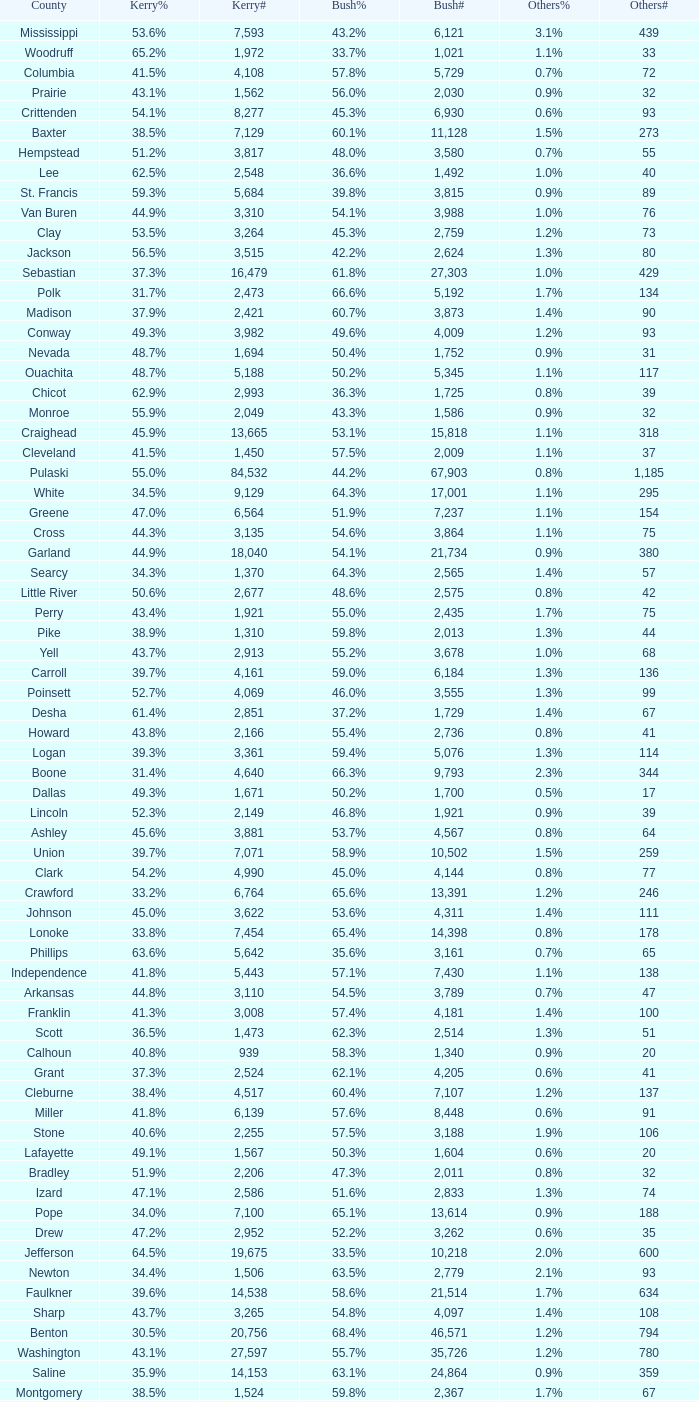Give me the full table as a dictionary. {'header': ['County', 'Kerry%', 'Kerry#', 'Bush%', 'Bush#', 'Others%', 'Others#'], 'rows': [['Mississippi', '53.6%', '7,593', '43.2%', '6,121', '3.1%', '439'], ['Woodruff', '65.2%', '1,972', '33.7%', '1,021', '1.1%', '33'], ['Columbia', '41.5%', '4,108', '57.8%', '5,729', '0.7%', '72'], ['Prairie', '43.1%', '1,562', '56.0%', '2,030', '0.9%', '32'], ['Crittenden', '54.1%', '8,277', '45.3%', '6,930', '0.6%', '93'], ['Baxter', '38.5%', '7,129', '60.1%', '11,128', '1.5%', '273'], ['Hempstead', '51.2%', '3,817', '48.0%', '3,580', '0.7%', '55'], ['Lee', '62.5%', '2,548', '36.6%', '1,492', '1.0%', '40'], ['St. Francis', '59.3%', '5,684', '39.8%', '3,815', '0.9%', '89'], ['Van Buren', '44.9%', '3,310', '54.1%', '3,988', '1.0%', '76'], ['Clay', '53.5%', '3,264', '45.3%', '2,759', '1.2%', '73'], ['Jackson', '56.5%', '3,515', '42.2%', '2,624', '1.3%', '80'], ['Sebastian', '37.3%', '16,479', '61.8%', '27,303', '1.0%', '429'], ['Polk', '31.7%', '2,473', '66.6%', '5,192', '1.7%', '134'], ['Madison', '37.9%', '2,421', '60.7%', '3,873', '1.4%', '90'], ['Conway', '49.3%', '3,982', '49.6%', '4,009', '1.2%', '93'], ['Nevada', '48.7%', '1,694', '50.4%', '1,752', '0.9%', '31'], ['Ouachita', '48.7%', '5,188', '50.2%', '5,345', '1.1%', '117'], ['Chicot', '62.9%', '2,993', '36.3%', '1,725', '0.8%', '39'], ['Monroe', '55.9%', '2,049', '43.3%', '1,586', '0.9%', '32'], ['Craighead', '45.9%', '13,665', '53.1%', '15,818', '1.1%', '318'], ['Cleveland', '41.5%', '1,450', '57.5%', '2,009', '1.1%', '37'], ['Pulaski', '55.0%', '84,532', '44.2%', '67,903', '0.8%', '1,185'], ['White', '34.5%', '9,129', '64.3%', '17,001', '1.1%', '295'], ['Greene', '47.0%', '6,564', '51.9%', '7,237', '1.1%', '154'], ['Cross', '44.3%', '3,135', '54.6%', '3,864', '1.1%', '75'], ['Garland', '44.9%', '18,040', '54.1%', '21,734', '0.9%', '380'], ['Searcy', '34.3%', '1,370', '64.3%', '2,565', '1.4%', '57'], ['Little River', '50.6%', '2,677', '48.6%', '2,575', '0.8%', '42'], ['Perry', '43.4%', '1,921', '55.0%', '2,435', '1.7%', '75'], ['Pike', '38.9%', '1,310', '59.8%', '2,013', '1.3%', '44'], ['Yell', '43.7%', '2,913', '55.2%', '3,678', '1.0%', '68'], ['Carroll', '39.7%', '4,161', '59.0%', '6,184', '1.3%', '136'], ['Poinsett', '52.7%', '4,069', '46.0%', '3,555', '1.3%', '99'], ['Desha', '61.4%', '2,851', '37.2%', '1,729', '1.4%', '67'], ['Howard', '43.8%', '2,166', '55.4%', '2,736', '0.8%', '41'], ['Logan', '39.3%', '3,361', '59.4%', '5,076', '1.3%', '114'], ['Boone', '31.4%', '4,640', '66.3%', '9,793', '2.3%', '344'], ['Dallas', '49.3%', '1,671', '50.2%', '1,700', '0.5%', '17'], ['Lincoln', '52.3%', '2,149', '46.8%', '1,921', '0.9%', '39'], ['Ashley', '45.6%', '3,881', '53.7%', '4,567', '0.8%', '64'], ['Union', '39.7%', '7,071', '58.9%', '10,502', '1.5%', '259'], ['Clark', '54.2%', '4,990', '45.0%', '4,144', '0.8%', '77'], ['Crawford', '33.2%', '6,764', '65.6%', '13,391', '1.2%', '246'], ['Johnson', '45.0%', '3,622', '53.6%', '4,311', '1.4%', '111'], ['Lonoke', '33.8%', '7,454', '65.4%', '14,398', '0.8%', '178'], ['Phillips', '63.6%', '5,642', '35.6%', '3,161', '0.7%', '65'], ['Independence', '41.8%', '5,443', '57.1%', '7,430', '1.1%', '138'], ['Arkansas', '44.8%', '3,110', '54.5%', '3,789', '0.7%', '47'], ['Franklin', '41.3%', '3,008', '57.4%', '4,181', '1.4%', '100'], ['Scott', '36.5%', '1,473', '62.3%', '2,514', '1.3%', '51'], ['Calhoun', '40.8%', '939', '58.3%', '1,340', '0.9%', '20'], ['Grant', '37.3%', '2,524', '62.1%', '4,205', '0.6%', '41'], ['Cleburne', '38.4%', '4,517', '60.4%', '7,107', '1.2%', '137'], ['Miller', '41.8%', '6,139', '57.6%', '8,448', '0.6%', '91'], ['Stone', '40.6%', '2,255', '57.5%', '3,188', '1.9%', '106'], ['Lafayette', '49.1%', '1,567', '50.3%', '1,604', '0.6%', '20'], ['Bradley', '51.9%', '2,206', '47.3%', '2,011', '0.8%', '32'], ['Izard', '47.1%', '2,586', '51.6%', '2,833', '1.3%', '74'], ['Pope', '34.0%', '7,100', '65.1%', '13,614', '0.9%', '188'], ['Drew', '47.2%', '2,952', '52.2%', '3,262', '0.6%', '35'], ['Jefferson', '64.5%', '19,675', '33.5%', '10,218', '2.0%', '600'], ['Newton', '34.4%', '1,506', '63.5%', '2,779', '2.1%', '93'], ['Faulkner', '39.6%', '14,538', '58.6%', '21,514', '1.7%', '634'], ['Sharp', '43.7%', '3,265', '54.8%', '4,097', '1.4%', '108'], ['Benton', '30.5%', '20,756', '68.4%', '46,571', '1.2%', '794'], ['Washington', '43.1%', '27,597', '55.7%', '35,726', '1.2%', '780'], ['Saline', '35.9%', '14,153', '63.1%', '24,864', '0.9%', '359'], ['Montgomery', '38.5%', '1,524', '59.8%', '2,367', '1.7%', '67'], ['Sevier', '44.2%', '2,035', '54.7%', '2,516', '1.1%', '50'], ['Fulton', '47.8%', '2,370', '50.9%', '2,522', '1.3%', '63'], ['Randolph', '51.2%', '3,412', '47.4%', '3,158', '1.5%', '97'], ['Marion', '37.9%', '2,602', '60.1%', '4,127', '2.0%', '138'], ['Hot Spring', '48.9%', '5,901', '49.4%', '5,960', '1.7%', '204'], ['Lawrence', '53.6%', '3,544', '44.6%', '2,951', '1.8%', '120']]} What is the lowest Kerry#, when Others# is "106", and when Bush# is less than 3,188? None. 